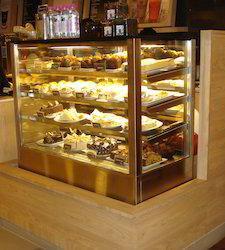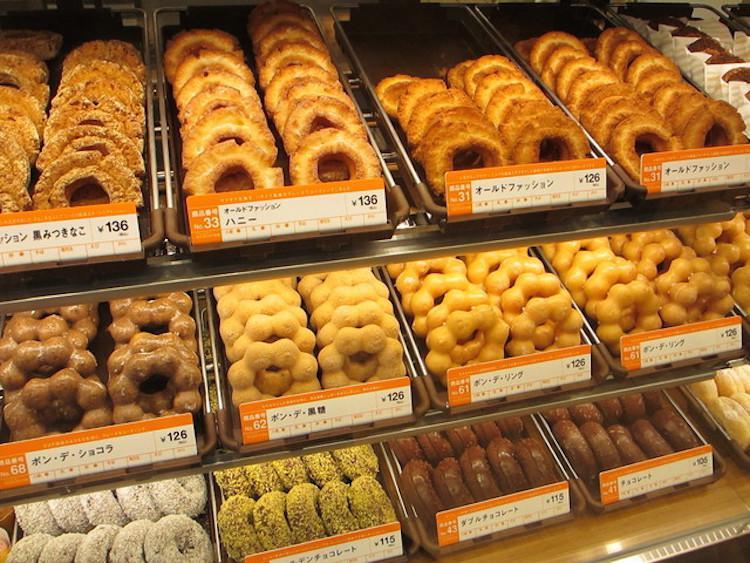The first image is the image on the left, the second image is the image on the right. For the images displayed, is the sentence "The left image features at least one pendant light in the bakery." factually correct? Answer yes or no. No. The first image is the image on the left, the second image is the image on the right. For the images shown, is this caption "There are baked goods in baskets in one of the images." true? Answer yes or no. No. 